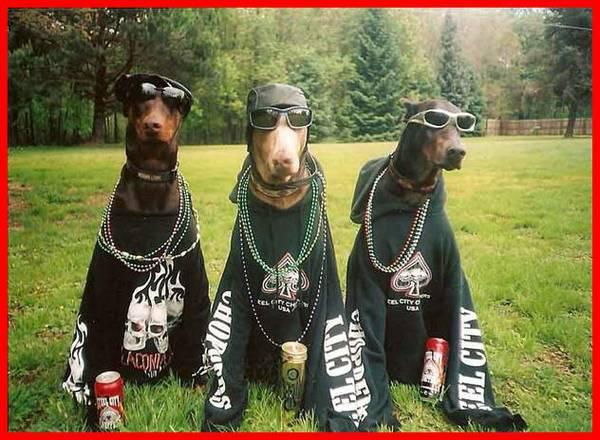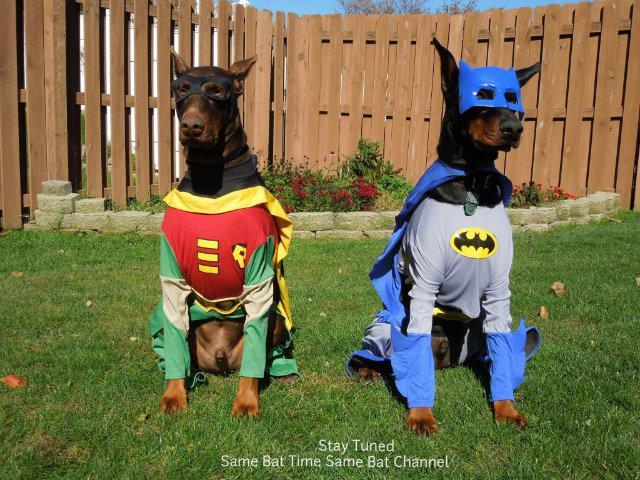The first image is the image on the left, the second image is the image on the right. Evaluate the accuracy of this statement regarding the images: "The left and right image contains the same number of dogs.". Is it true? Answer yes or no. No. The first image is the image on the left, the second image is the image on the right. Considering the images on both sides, is "The left image shows an open-mouthed doberman reclining on the grass by a young 'creature' of some type." valid? Answer yes or no. No. 